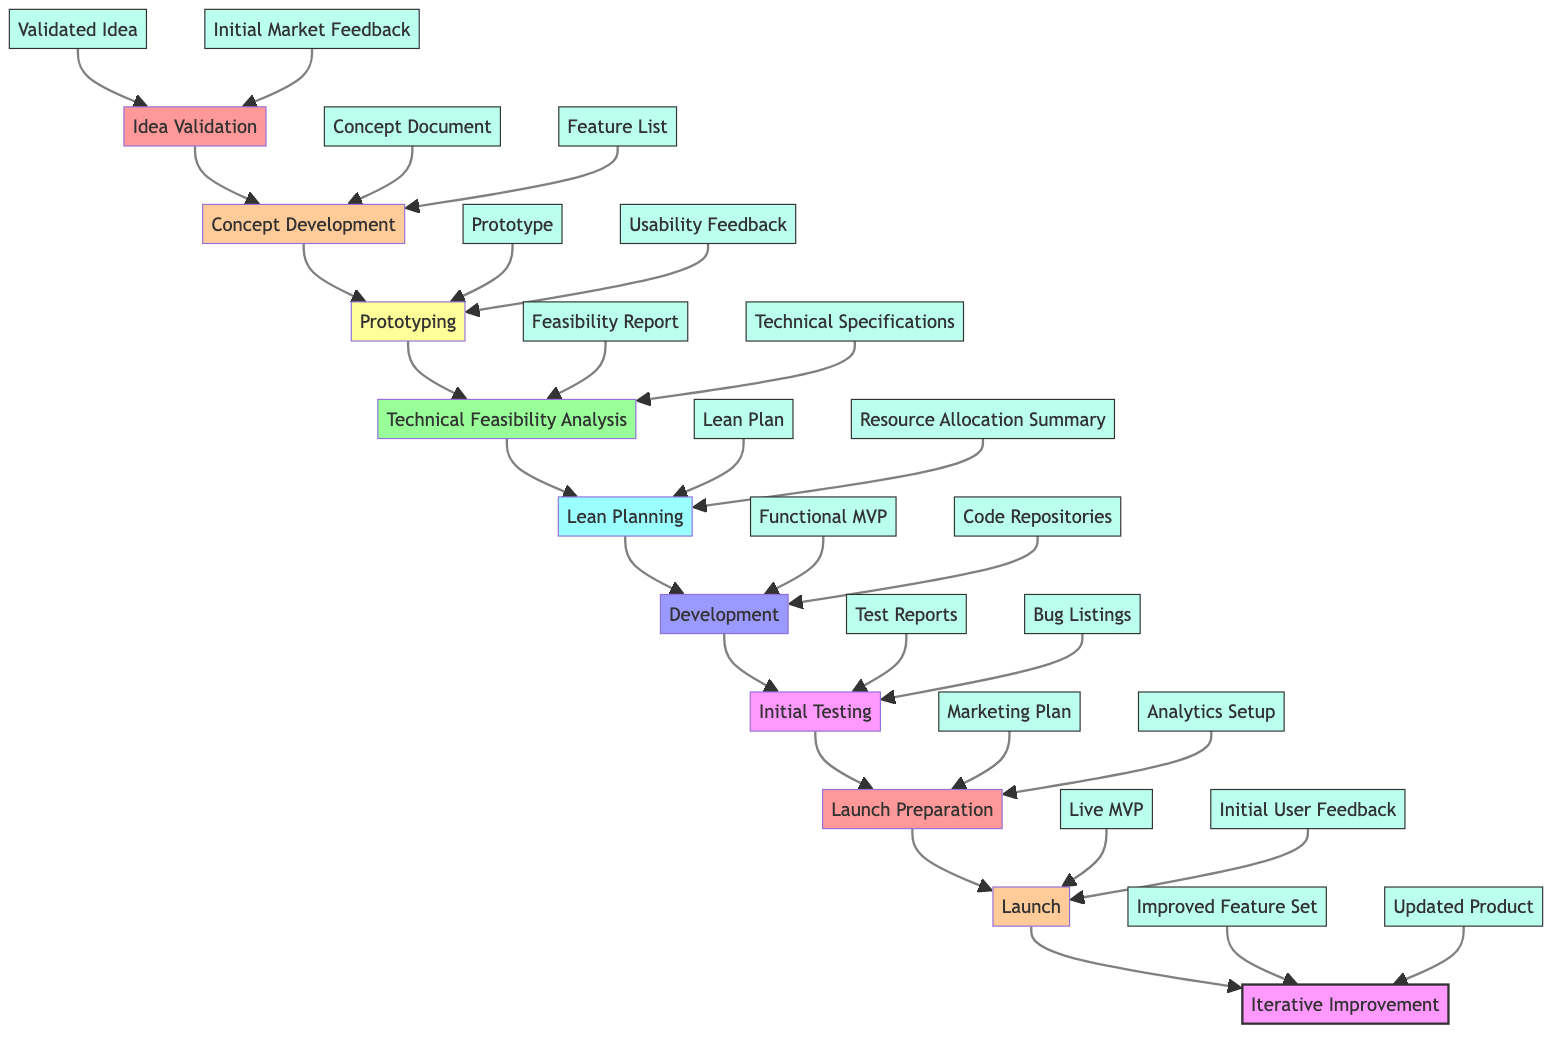What is the first step in the development workflow? The flowchart starts at the bottom with the first step labeled "Idea Validation." This is the initial stage of the process, indicating that validation of the product idea is crucial before moving on to subsequent steps.
Answer: Idea Validation How many steps are there in total? By counting the labeled steps in the diagram from Idea Validation to Iterative Improvement, we find there are ten distinct steps outlined in the workflow.
Answer: Ten What is the output of the "Development" step? The goals of the "Development" step include producing a "Functional MVP" and "Code Repositories" as its primary outputs, which are necessary for the MVP implementation.
Answer: Functional MVP, Code Repositories Which step comes after "Launch Preparation"? Following the "Launch Preparation" step, the next step in the flow is "Launch." This indicates that preparations lead directly into launching the MVP to the market segment.
Answer: Launch What tools are used in the "Prototyping" step? The tools listed for the "Prototyping" step include "Wireframes," "Mockups," and "Clickable Prototypes." These tools are essential for visualizing and testing the core features of the product.
Answer: Wireframes, Mockups, Clickable Prototypes In which step is market feedback gathered? Market feedback is gathered during the "Idea Validation" step, where surveys and focus groups are utilized to confirm the viability of the product idea before any further development occurs.
Answer: Idea Validation What are the outputs from "Initial Testing"? The "Initial Testing" step produces "Test Reports" and "Bug Listings" as outputs, both of which are critical for understanding the performance and quality of the MVP before the final launch.
Answer: Test Reports, Bug Listings Which step involves creating a marketing plan? The "Launch Preparation" step specifically focuses on creating a marketing plan, which is a vital part of the strategy before the product is launched to ensure effective promotion and adoption.
Answer: Launch Preparation What comes before the "Iterative Improvement" step? Before "Iterative Improvement," the step "Launch" occurs, marking the transition from deployment to gathering user feedback for ongoing enhancements of the MVP.
Answer: Launch 